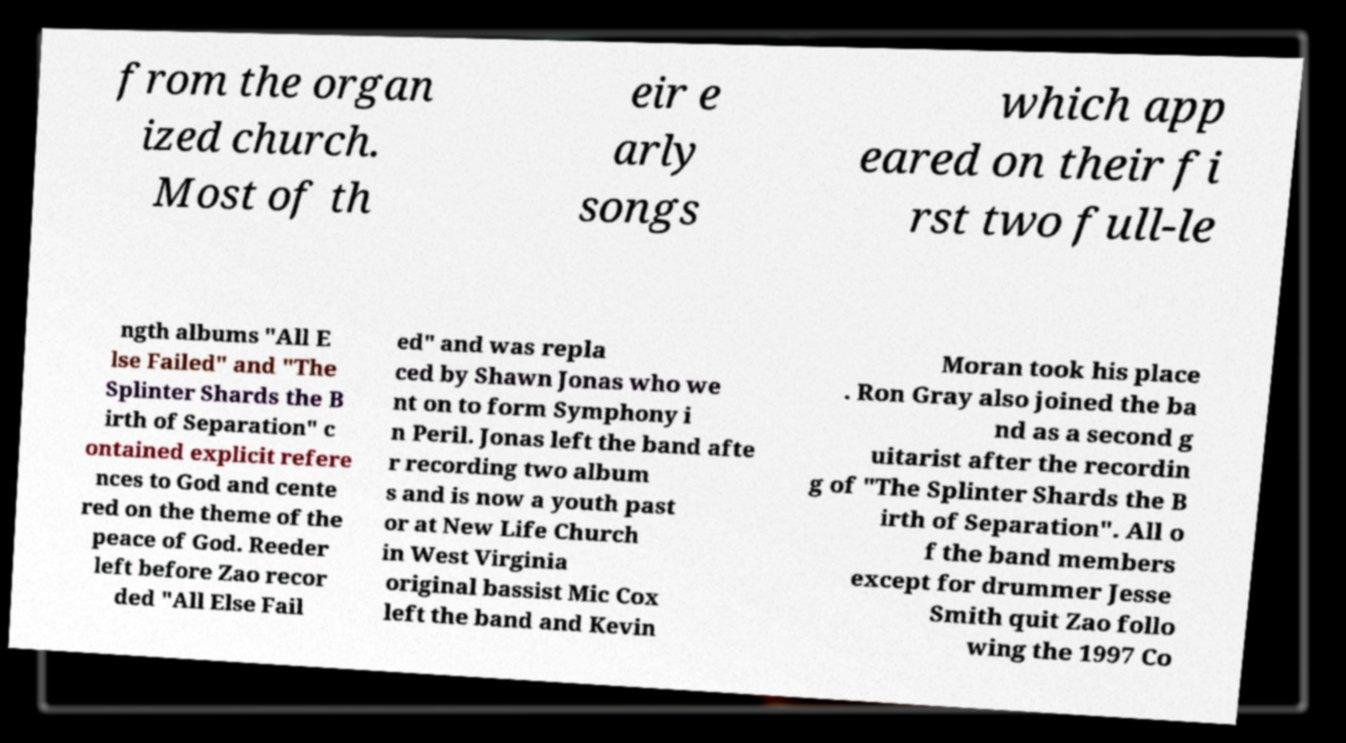Please identify and transcribe the text found in this image. from the organ ized church. Most of th eir e arly songs which app eared on their fi rst two full-le ngth albums "All E lse Failed" and "The Splinter Shards the B irth of Separation" c ontained explicit refere nces to God and cente red on the theme of the peace of God. Reeder left before Zao recor ded "All Else Fail ed" and was repla ced by Shawn Jonas who we nt on to form Symphony i n Peril. Jonas left the band afte r recording two album s and is now a youth past or at New Life Church in West Virginia original bassist Mic Cox left the band and Kevin Moran took his place . Ron Gray also joined the ba nd as a second g uitarist after the recordin g of "The Splinter Shards the B irth of Separation". All o f the band members except for drummer Jesse Smith quit Zao follo wing the 1997 Co 